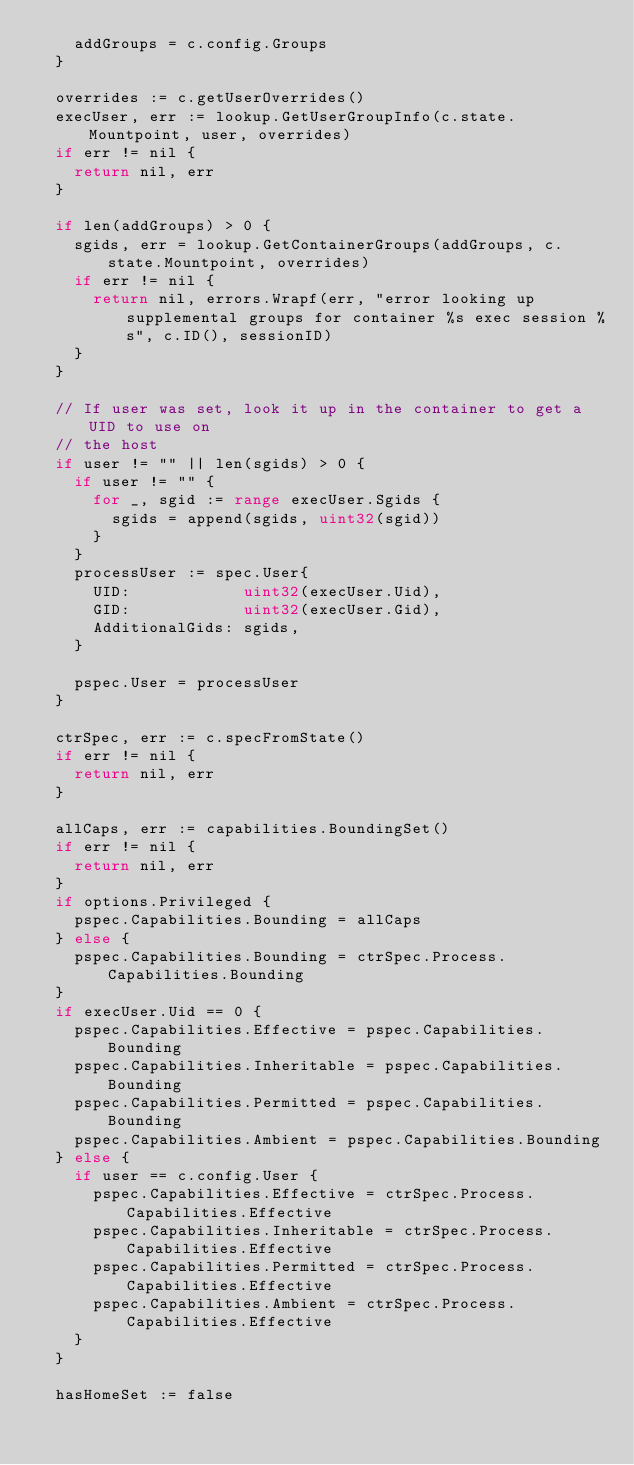<code> <loc_0><loc_0><loc_500><loc_500><_Go_>		addGroups = c.config.Groups
	}

	overrides := c.getUserOverrides()
	execUser, err := lookup.GetUserGroupInfo(c.state.Mountpoint, user, overrides)
	if err != nil {
		return nil, err
	}

	if len(addGroups) > 0 {
		sgids, err = lookup.GetContainerGroups(addGroups, c.state.Mountpoint, overrides)
		if err != nil {
			return nil, errors.Wrapf(err, "error looking up supplemental groups for container %s exec session %s", c.ID(), sessionID)
		}
	}

	// If user was set, look it up in the container to get a UID to use on
	// the host
	if user != "" || len(sgids) > 0 {
		if user != "" {
			for _, sgid := range execUser.Sgids {
				sgids = append(sgids, uint32(sgid))
			}
		}
		processUser := spec.User{
			UID:            uint32(execUser.Uid),
			GID:            uint32(execUser.Gid),
			AdditionalGids: sgids,
		}

		pspec.User = processUser
	}

	ctrSpec, err := c.specFromState()
	if err != nil {
		return nil, err
	}

	allCaps, err := capabilities.BoundingSet()
	if err != nil {
		return nil, err
	}
	if options.Privileged {
		pspec.Capabilities.Bounding = allCaps
	} else {
		pspec.Capabilities.Bounding = ctrSpec.Process.Capabilities.Bounding
	}
	if execUser.Uid == 0 {
		pspec.Capabilities.Effective = pspec.Capabilities.Bounding
		pspec.Capabilities.Inheritable = pspec.Capabilities.Bounding
		pspec.Capabilities.Permitted = pspec.Capabilities.Bounding
		pspec.Capabilities.Ambient = pspec.Capabilities.Bounding
	} else {
		if user == c.config.User {
			pspec.Capabilities.Effective = ctrSpec.Process.Capabilities.Effective
			pspec.Capabilities.Inheritable = ctrSpec.Process.Capabilities.Effective
			pspec.Capabilities.Permitted = ctrSpec.Process.Capabilities.Effective
			pspec.Capabilities.Ambient = ctrSpec.Process.Capabilities.Effective
		}
	}

	hasHomeSet := false</code> 